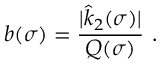Convert formula to latex. <formula><loc_0><loc_0><loc_500><loc_500>b ( \sigma ) = \frac { | \hat { k } _ { 2 } ( \sigma ) | } { Q ( \sigma ) } \ .</formula> 